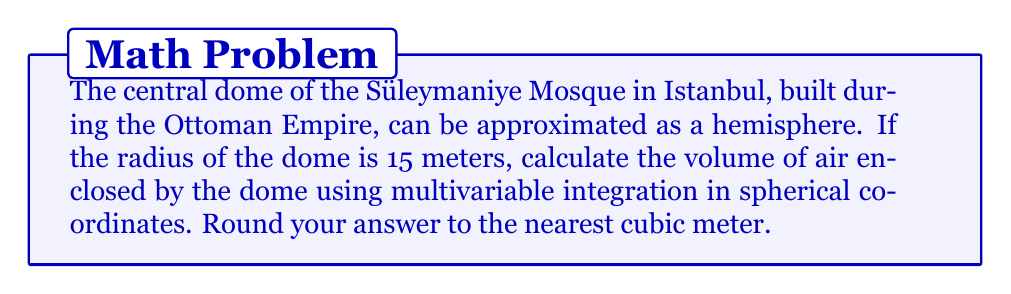Provide a solution to this math problem. To solve this problem, we'll use the formula for the volume of a solid in spherical coordinates:

$$ V = \iiint_D r^2 \sin\phi \, dr \, d\phi \, d\theta $$

Where:
- $r$ is the radius (0 to 15 meters)
- $\phi$ is the polar angle (0 to $\pi/2$ radians for a hemisphere)
- $\theta$ is the azimuthal angle (0 to $2\pi$ radians)

Steps:
1) Set up the triple integral:

$$ V = \int_0^{2\pi} \int_0^{\pi/2} \int_0^{15} r^2 \sin\phi \, dr \, d\phi \, d\theta $$

2) Integrate with respect to $r$:

$$ V = \int_0^{2\pi} \int_0^{\pi/2} \left[\frac{1}{3}r^3\right]_0^{15} \sin\phi \, d\phi \, d\theta $$
$$ V = \int_0^{2\pi} \int_0^{\pi/2} \frac{1}{3}(15^3) \sin\phi \, d\phi \, d\theta $$

3) Integrate with respect to $\phi$:

$$ V = \int_0^{2\pi} \left[-\frac{1}{3}(15^3) \cos\phi\right]_0^{\pi/2} \, d\theta $$
$$ V = \int_0^{2\pi} \frac{1}{3}(15^3) \, d\theta $$

4) Integrate with respect to $\theta$:

$$ V = \left[\frac{1}{3}(15^3) \theta\right]_0^{2\pi} $$
$$ V = \frac{1}{3}(15^3) (2\pi) $$

5) Calculate the final result:

$$ V = \frac{2\pi}{3}(15^3) = \frac{2\pi}{3}(3375) = 2250\pi \approx 7068.58 \text{ m}^3 $$

Rounding to the nearest cubic meter gives us 7069 m³.
Answer: 7069 m³ 